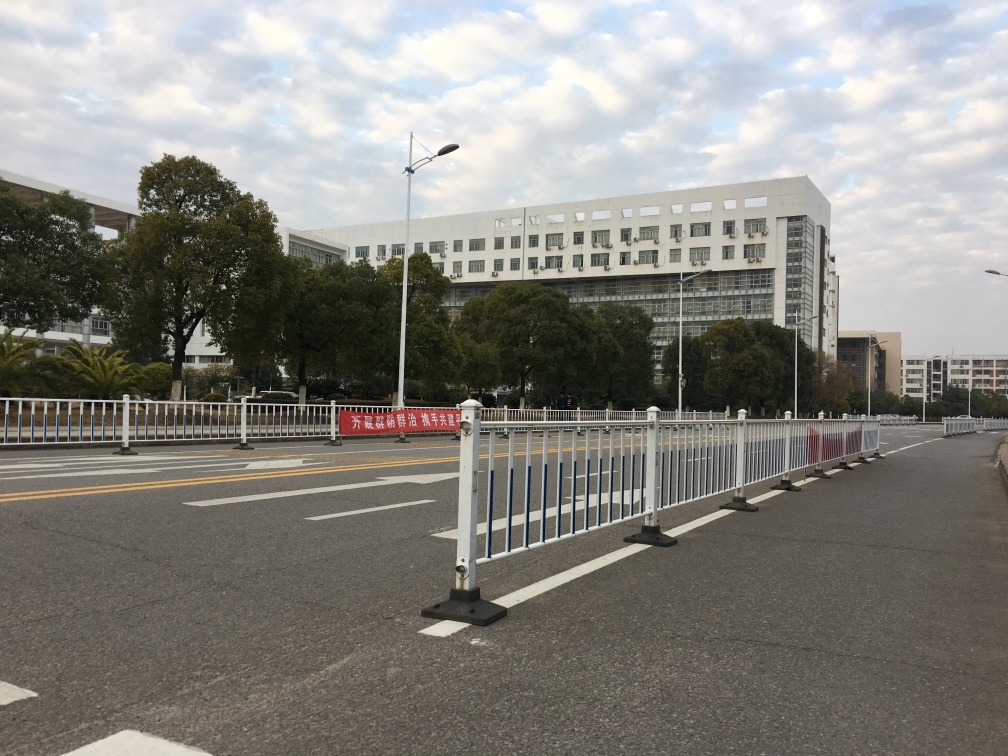Are there any indications of cultural or regional characteristics in the image? The writing on the red banner, the style of guardrails, and the architectural design of the building suggest that the image may have been taken in a region where the local language is written with characters, likely in East Asia. These elements can provide hints about the cultural or geographical location of the scene. 